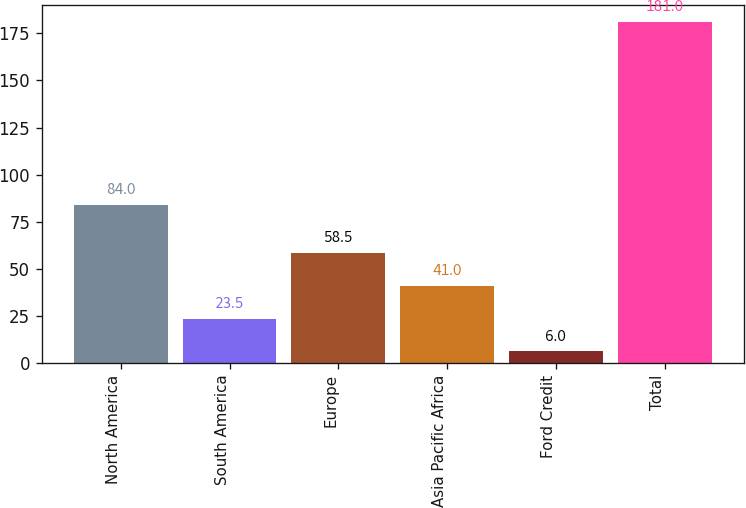<chart> <loc_0><loc_0><loc_500><loc_500><bar_chart><fcel>North America<fcel>South America<fcel>Europe<fcel>Asia Pacific Africa<fcel>Ford Credit<fcel>Total<nl><fcel>84<fcel>23.5<fcel>58.5<fcel>41<fcel>6<fcel>181<nl></chart> 